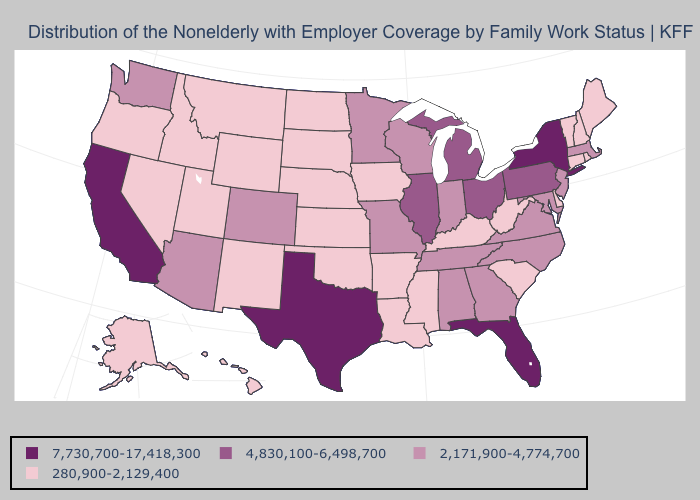Does Utah have the lowest value in the USA?
Write a very short answer. Yes. Name the states that have a value in the range 280,900-2,129,400?
Be succinct. Alaska, Arkansas, Connecticut, Delaware, Hawaii, Idaho, Iowa, Kansas, Kentucky, Louisiana, Maine, Mississippi, Montana, Nebraska, Nevada, New Hampshire, New Mexico, North Dakota, Oklahoma, Oregon, Rhode Island, South Carolina, South Dakota, Utah, Vermont, West Virginia, Wyoming. What is the value of Oregon?
Give a very brief answer. 280,900-2,129,400. What is the value of New Mexico?
Short answer required. 280,900-2,129,400. Which states have the highest value in the USA?
Be succinct. California, Florida, New York, Texas. Name the states that have a value in the range 7,730,700-17,418,300?
Answer briefly. California, Florida, New York, Texas. What is the value of Connecticut?
Concise answer only. 280,900-2,129,400. What is the value of South Carolina?
Answer briefly. 280,900-2,129,400. Name the states that have a value in the range 4,830,100-6,498,700?
Quick response, please. Illinois, Michigan, Ohio, Pennsylvania. Name the states that have a value in the range 2,171,900-4,774,700?
Short answer required. Alabama, Arizona, Colorado, Georgia, Indiana, Maryland, Massachusetts, Minnesota, Missouri, New Jersey, North Carolina, Tennessee, Virginia, Washington, Wisconsin. What is the lowest value in states that border South Carolina?
Keep it brief. 2,171,900-4,774,700. Name the states that have a value in the range 2,171,900-4,774,700?
Answer briefly. Alabama, Arizona, Colorado, Georgia, Indiana, Maryland, Massachusetts, Minnesota, Missouri, New Jersey, North Carolina, Tennessee, Virginia, Washington, Wisconsin. What is the lowest value in the USA?
Keep it brief. 280,900-2,129,400. Name the states that have a value in the range 280,900-2,129,400?
Answer briefly. Alaska, Arkansas, Connecticut, Delaware, Hawaii, Idaho, Iowa, Kansas, Kentucky, Louisiana, Maine, Mississippi, Montana, Nebraska, Nevada, New Hampshire, New Mexico, North Dakota, Oklahoma, Oregon, Rhode Island, South Carolina, South Dakota, Utah, Vermont, West Virginia, Wyoming. Does Maryland have the lowest value in the USA?
Answer briefly. No. 